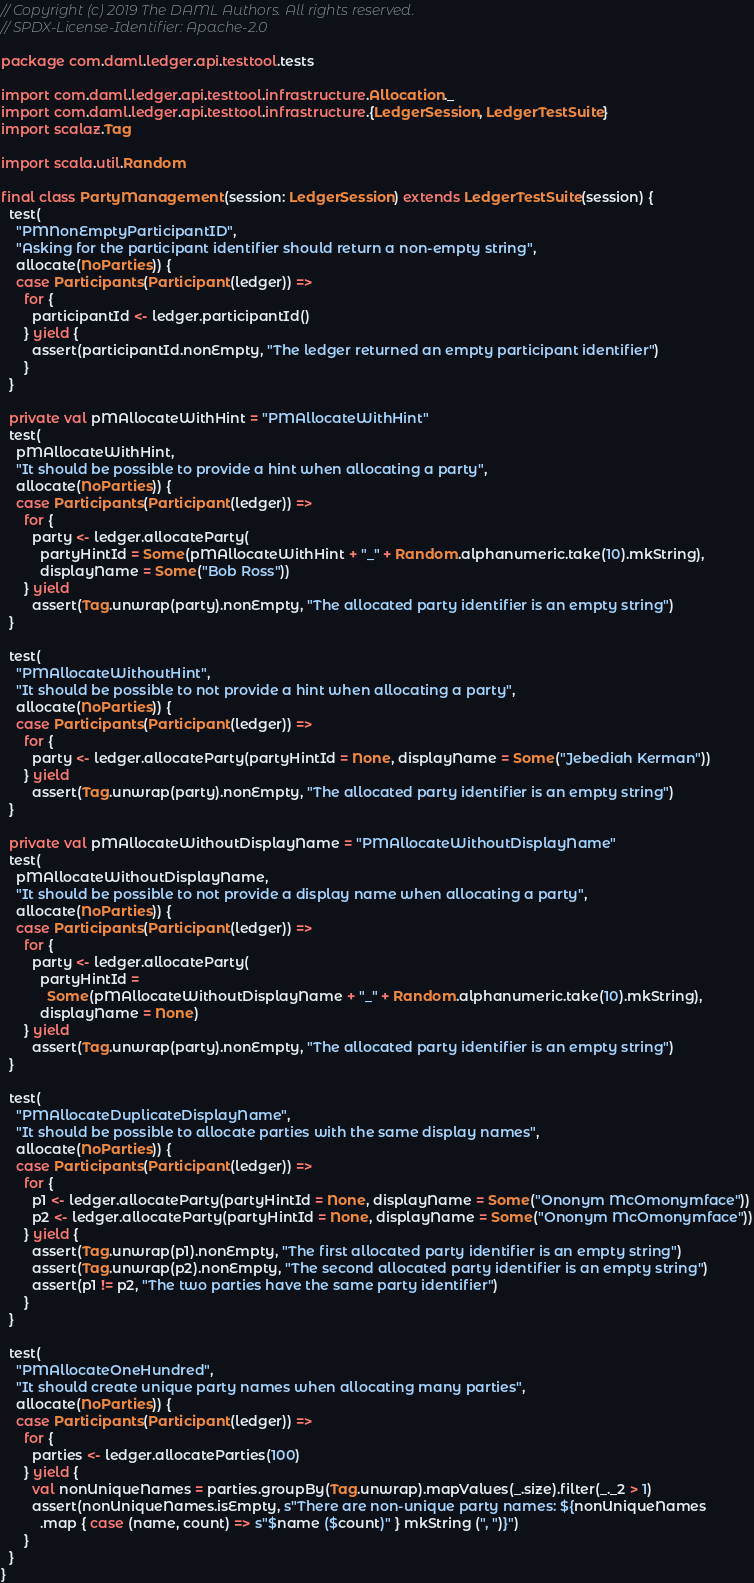Convert code to text. <code><loc_0><loc_0><loc_500><loc_500><_Scala_>// Copyright (c) 2019 The DAML Authors. All rights reserved.
// SPDX-License-Identifier: Apache-2.0

package com.daml.ledger.api.testtool.tests

import com.daml.ledger.api.testtool.infrastructure.Allocation._
import com.daml.ledger.api.testtool.infrastructure.{LedgerSession, LedgerTestSuite}
import scalaz.Tag

import scala.util.Random

final class PartyManagement(session: LedgerSession) extends LedgerTestSuite(session) {
  test(
    "PMNonEmptyParticipantID",
    "Asking for the participant identifier should return a non-empty string",
    allocate(NoParties)) {
    case Participants(Participant(ledger)) =>
      for {
        participantId <- ledger.participantId()
      } yield {
        assert(participantId.nonEmpty, "The ledger returned an empty participant identifier")
      }
  }

  private val pMAllocateWithHint = "PMAllocateWithHint"
  test(
    pMAllocateWithHint,
    "It should be possible to provide a hint when allocating a party",
    allocate(NoParties)) {
    case Participants(Participant(ledger)) =>
      for {
        party <- ledger.allocateParty(
          partyHintId = Some(pMAllocateWithHint + "_" + Random.alphanumeric.take(10).mkString),
          displayName = Some("Bob Ross"))
      } yield
        assert(Tag.unwrap(party).nonEmpty, "The allocated party identifier is an empty string")
  }

  test(
    "PMAllocateWithoutHint",
    "It should be possible to not provide a hint when allocating a party",
    allocate(NoParties)) {
    case Participants(Participant(ledger)) =>
      for {
        party <- ledger.allocateParty(partyHintId = None, displayName = Some("Jebediah Kerman"))
      } yield
        assert(Tag.unwrap(party).nonEmpty, "The allocated party identifier is an empty string")
  }

  private val pMAllocateWithoutDisplayName = "PMAllocateWithoutDisplayName"
  test(
    pMAllocateWithoutDisplayName,
    "It should be possible to not provide a display name when allocating a party",
    allocate(NoParties)) {
    case Participants(Participant(ledger)) =>
      for {
        party <- ledger.allocateParty(
          partyHintId =
            Some(pMAllocateWithoutDisplayName + "_" + Random.alphanumeric.take(10).mkString),
          displayName = None)
      } yield
        assert(Tag.unwrap(party).nonEmpty, "The allocated party identifier is an empty string")
  }

  test(
    "PMAllocateDuplicateDisplayName",
    "It should be possible to allocate parties with the same display names",
    allocate(NoParties)) {
    case Participants(Participant(ledger)) =>
      for {
        p1 <- ledger.allocateParty(partyHintId = None, displayName = Some("Ononym McOmonymface"))
        p2 <- ledger.allocateParty(partyHintId = None, displayName = Some("Ononym McOmonymface"))
      } yield {
        assert(Tag.unwrap(p1).nonEmpty, "The first allocated party identifier is an empty string")
        assert(Tag.unwrap(p2).nonEmpty, "The second allocated party identifier is an empty string")
        assert(p1 != p2, "The two parties have the same party identifier")
      }
  }

  test(
    "PMAllocateOneHundred",
    "It should create unique party names when allocating many parties",
    allocate(NoParties)) {
    case Participants(Participant(ledger)) =>
      for {
        parties <- ledger.allocateParties(100)
      } yield {
        val nonUniqueNames = parties.groupBy(Tag.unwrap).mapValues(_.size).filter(_._2 > 1)
        assert(nonUniqueNames.isEmpty, s"There are non-unique party names: ${nonUniqueNames
          .map { case (name, count) => s"$name ($count)" } mkString (", ")}")
      }
  }
}
</code> 